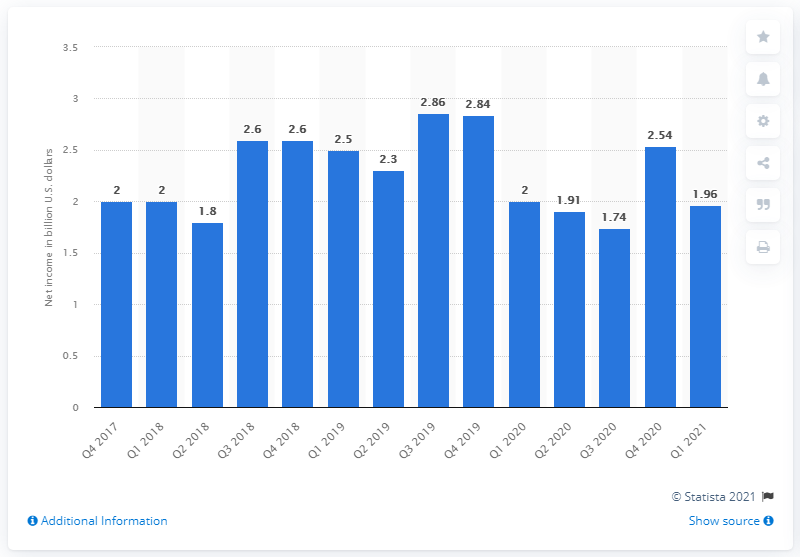Draw attention to some important aspects in this diagram. In the first quarter of 2021, WarnerMedia's operating income was 1.96 billion dollars. 